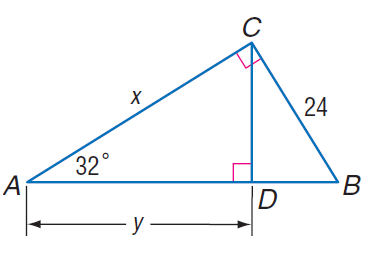Answer the mathemtical geometry problem and directly provide the correct option letter.
Question: Find y.
Choices: A: 21.4 B: 24.1 C: 32.6 D: 43.1 C 